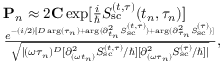<formula> <loc_0><loc_0><loc_500><loc_500>\begin{array} { r l } & { { P } _ { n } \approx 2 { C } \exp [ { \frac { i } { } S _ { s c } ^ { ( t , \tau ) } ( t _ { n } , \tau _ { n } ) } ] } \\ & { \frac { e ^ { - ( i / 2 ) [ D \arg ( \tau _ { n } ) + \arg ( { \partial _ { t _ { n } } ^ { 2 } S _ { s c } ^ { ( t , \tau ) } } ) + \arg ( { \partial _ { \tau _ { n } } ^ { 2 } S _ { s c } ^ { ( \tau ) } } ) ] } } { \sqrt { | ( \omega \tau _ { n } ) ^ { D } [ { \partial _ { ( \omega t _ { n } ) } ^ { 2 } S _ { s c } ^ { ( t , \tau ) } } / \hbar { ] } [ { \partial _ { ( \omega \tau _ { n } ) } ^ { 2 } S _ { s c } ^ { ( \tau ) } } / \hbar { ] } | } } , } \end{array}</formula> 